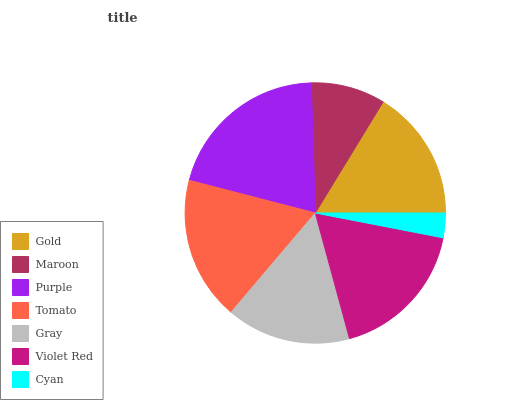Is Cyan the minimum?
Answer yes or no. Yes. Is Purple the maximum?
Answer yes or no. Yes. Is Maroon the minimum?
Answer yes or no. No. Is Maroon the maximum?
Answer yes or no. No. Is Gold greater than Maroon?
Answer yes or no. Yes. Is Maroon less than Gold?
Answer yes or no. Yes. Is Maroon greater than Gold?
Answer yes or no. No. Is Gold less than Maroon?
Answer yes or no. No. Is Gold the high median?
Answer yes or no. Yes. Is Gold the low median?
Answer yes or no. Yes. Is Purple the high median?
Answer yes or no. No. Is Tomato the low median?
Answer yes or no. No. 